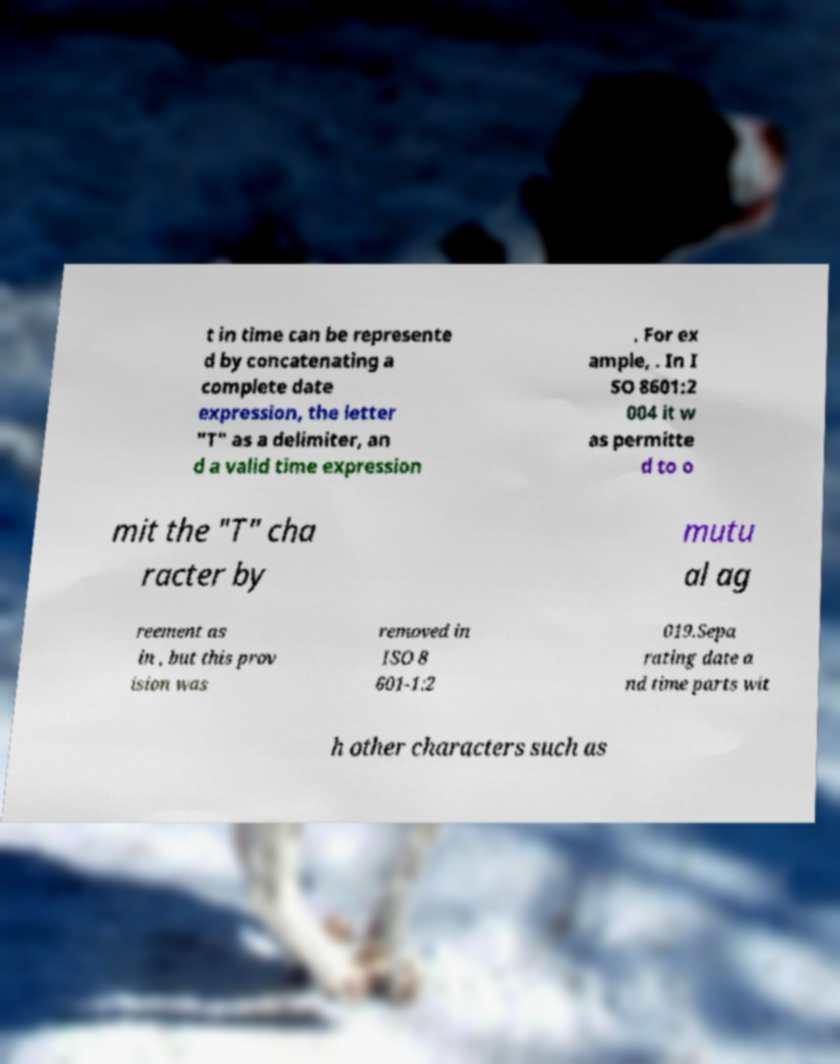Can you read and provide the text displayed in the image?This photo seems to have some interesting text. Can you extract and type it out for me? t in time can be represente d by concatenating a complete date expression, the letter "T" as a delimiter, an d a valid time expression . For ex ample, . In I SO 8601:2 004 it w as permitte d to o mit the "T" cha racter by mutu al ag reement as in , but this prov ision was removed in ISO 8 601-1:2 019.Sepa rating date a nd time parts wit h other characters such as 